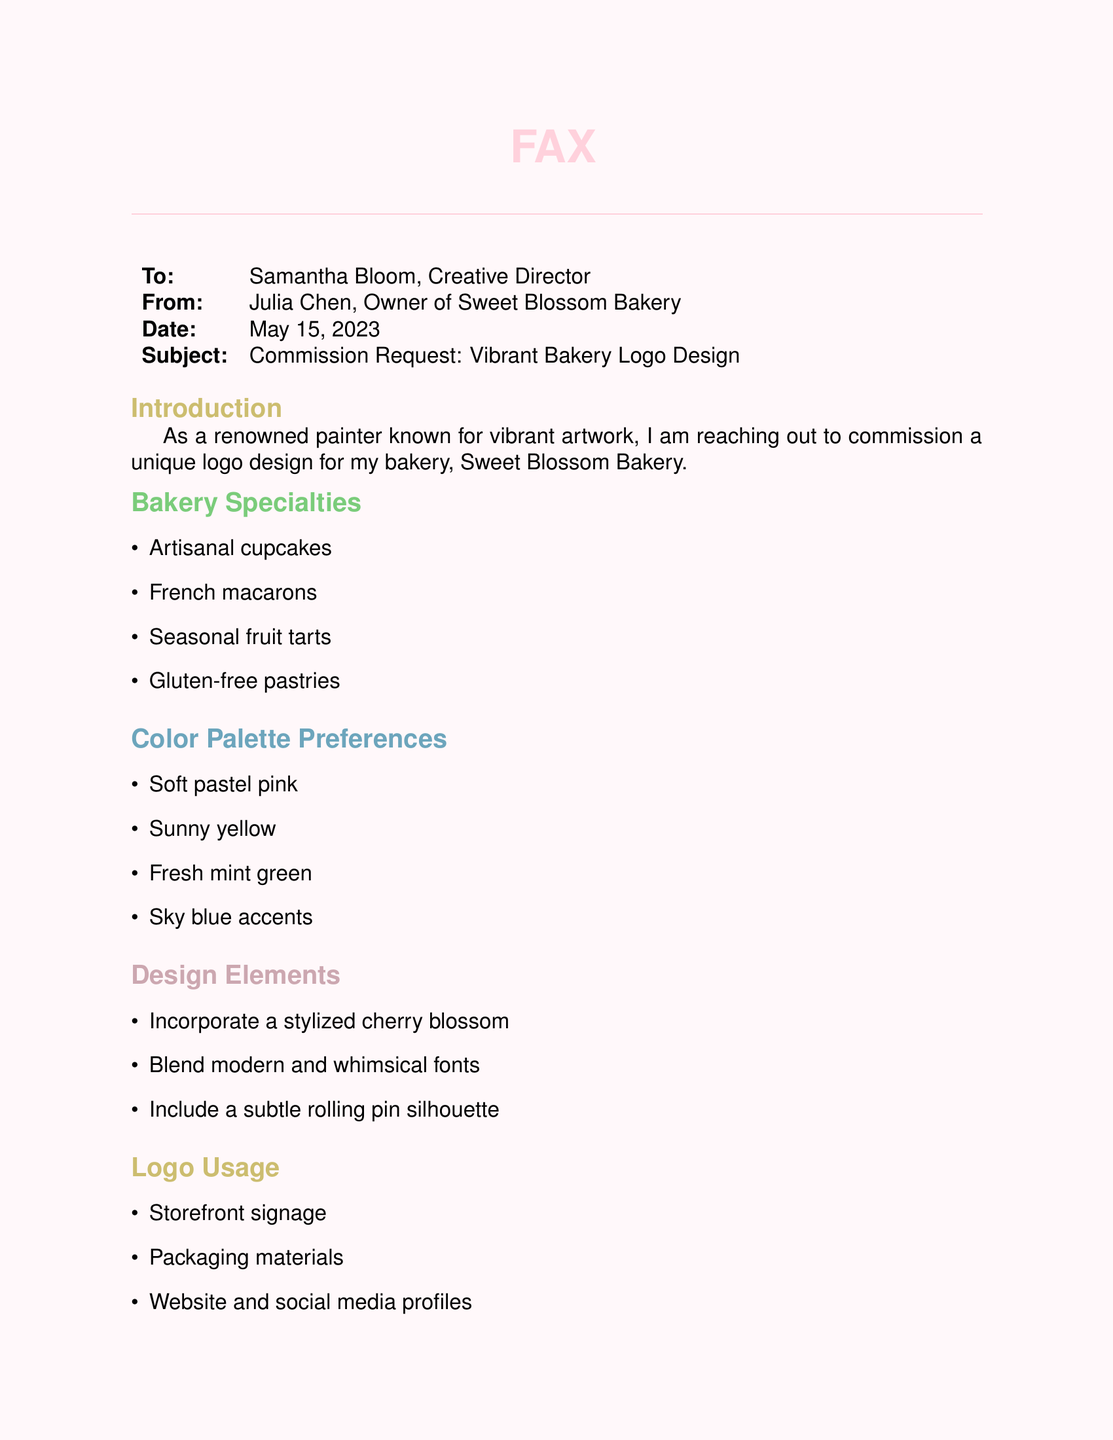What is the name of the bakery? The document states that the bakery is called Sweet Blossom Bakery.
Answer: Sweet Blossom Bakery Who is the Creative Director addressed in the fax? The fax is addressed to Samantha Bloom.
Answer: Samantha Bloom What is the commission budget range? The document specifies the budget range for the logo design as $800 to $1,200.
Answer: $800 - $1,200 When is the logo required? The document states that the logo is required within 3 weeks for the grand opening.
Answer: Within 3 weeks What is one of the bakery specialties mentioned? The document lists four bakery specialties, one of which is artisanal cupcakes.
Answer: Artisanal cupcakes What two color palette preferences are specified in the request? The color palette preferences include soft pastel pink and sunny yellow.
Answer: Soft pastel pink, sunny yellow What unique design element is to be included in the logo? The document specifies that a stylized cherry blossom should be incorporated into the logo design.
Answer: Stylized cherry blossom For what purposes will the logo be used? The document lists multiple uses for the logo, including storefront signage and social media profiles.
Answer: Storefront signage, packaging materials, website and social media profiles, business cards and flyers What date is mentioned in the fax? The date of the fax is mentioned as May 15, 2023.
Answer: May 15, 2023 